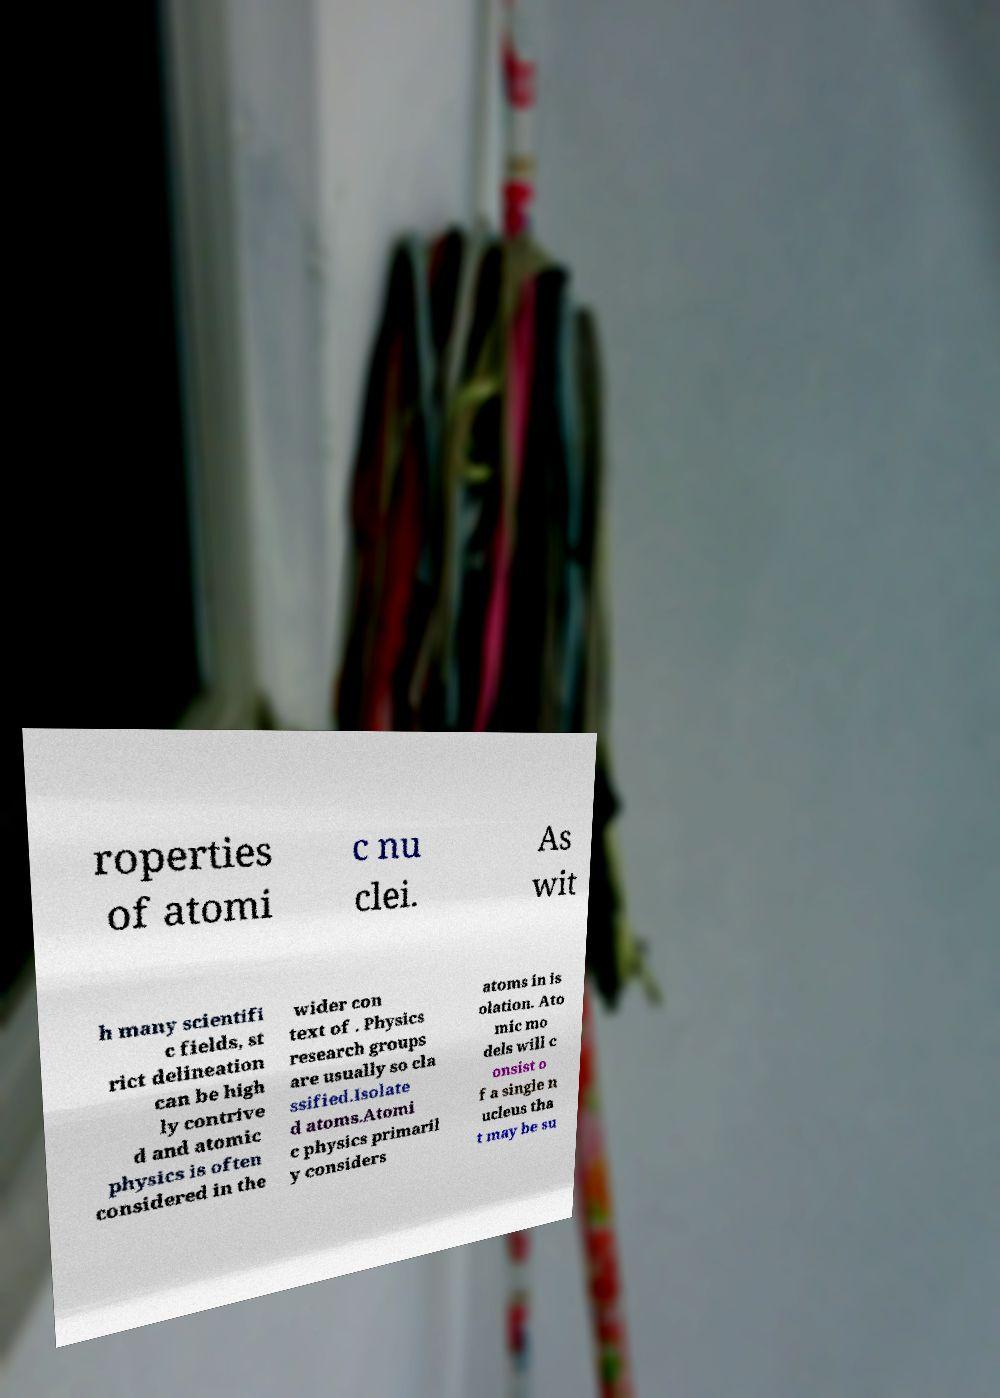There's text embedded in this image that I need extracted. Can you transcribe it verbatim? roperties of atomi c nu clei. As wit h many scientifi c fields, st rict delineation can be high ly contrive d and atomic physics is often considered in the wider con text of . Physics research groups are usually so cla ssified.Isolate d atoms.Atomi c physics primaril y considers atoms in is olation. Ato mic mo dels will c onsist o f a single n ucleus tha t may be su 